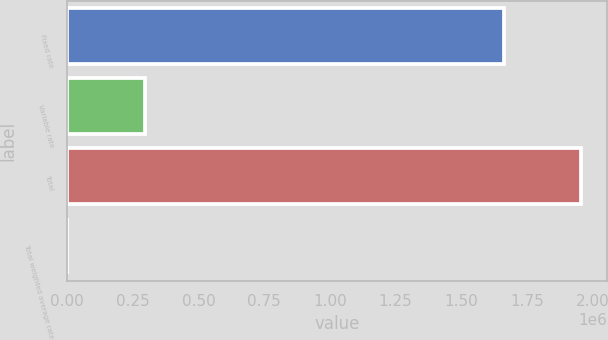Convert chart to OTSL. <chart><loc_0><loc_0><loc_500><loc_500><bar_chart><fcel>Fixed rate<fcel>Variable rate<fcel>Total<fcel>Total weighted average rate<nl><fcel>1.66317e+06<fcel>295265<fcel>1.95843e+06<fcel>6.14<nl></chart> 